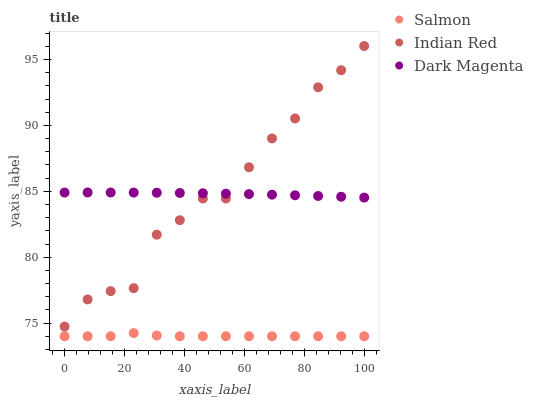Does Salmon have the minimum area under the curve?
Answer yes or no. Yes. Does Indian Red have the maximum area under the curve?
Answer yes or no. Yes. Does Dark Magenta have the minimum area under the curve?
Answer yes or no. No. Does Dark Magenta have the maximum area under the curve?
Answer yes or no. No. Is Dark Magenta the smoothest?
Answer yes or no. Yes. Is Indian Red the roughest?
Answer yes or no. Yes. Is Indian Red the smoothest?
Answer yes or no. No. Is Dark Magenta the roughest?
Answer yes or no. No. Does Salmon have the lowest value?
Answer yes or no. Yes. Does Indian Red have the lowest value?
Answer yes or no. No. Does Indian Red have the highest value?
Answer yes or no. Yes. Does Dark Magenta have the highest value?
Answer yes or no. No. Is Salmon less than Indian Red?
Answer yes or no. Yes. Is Dark Magenta greater than Salmon?
Answer yes or no. Yes. Does Dark Magenta intersect Indian Red?
Answer yes or no. Yes. Is Dark Magenta less than Indian Red?
Answer yes or no. No. Is Dark Magenta greater than Indian Red?
Answer yes or no. No. Does Salmon intersect Indian Red?
Answer yes or no. No. 